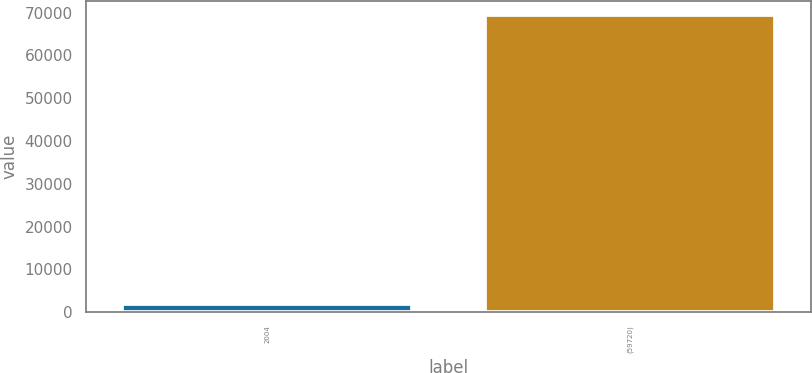<chart> <loc_0><loc_0><loc_500><loc_500><bar_chart><fcel>2004<fcel>(59720)<nl><fcel>2003<fcel>69354<nl></chart> 